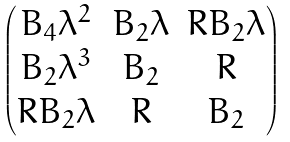Convert formula to latex. <formula><loc_0><loc_0><loc_500><loc_500>\begin{pmatrix} B _ { 4 } \lambda ^ { 2 } & B _ { 2 } \lambda & R B _ { 2 } \lambda \\ B _ { 2 } \lambda ^ { 3 } & B _ { 2 } & R \\ R B _ { 2 } \lambda & R & B _ { 2 } \end{pmatrix}</formula> 